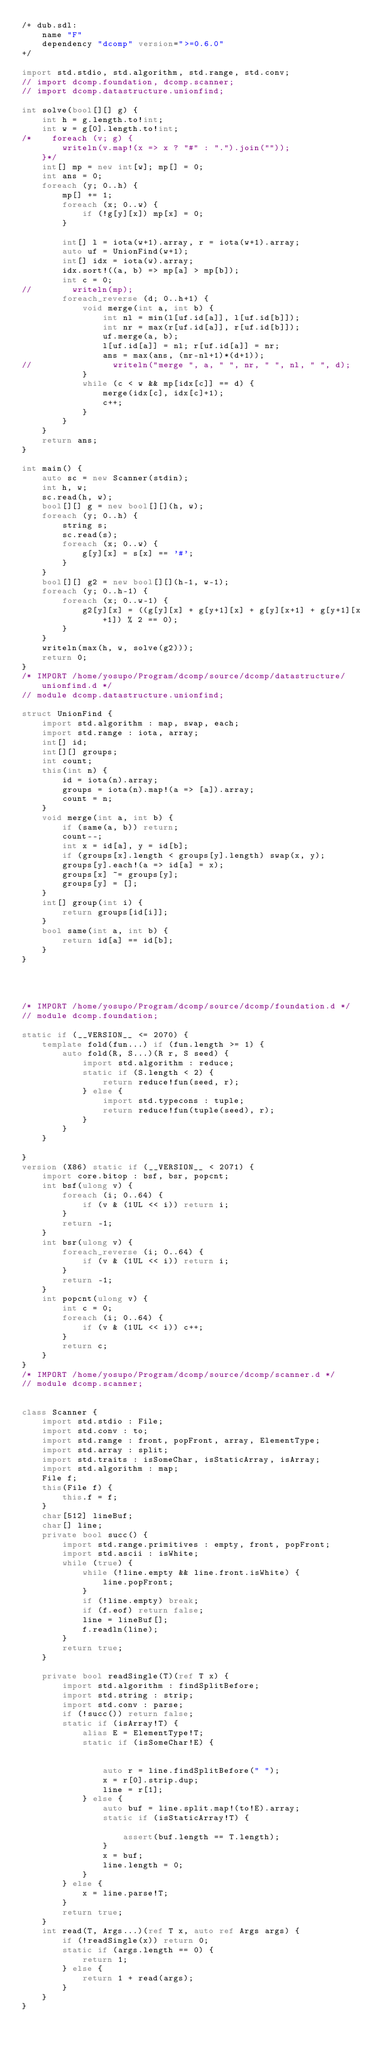Convert code to text. <code><loc_0><loc_0><loc_500><loc_500><_D_>/+ dub.sdl:
    name "F"
    dependency "dcomp" version=">=0.6.0"
+/

import std.stdio, std.algorithm, std.range, std.conv;
// import dcomp.foundation, dcomp.scanner;
// import dcomp.datastructure.unionfind;

int solve(bool[][] g) {
    int h = g.length.to!int;
    int w = g[0].length.to!int;
/*    foreach (v; g) {
        writeln(v.map!(x => x ? "#" : ".").join(""));
    }*/
    int[] mp = new int[w]; mp[] = 0;
    int ans = 0;
    foreach (y; 0..h) {
        mp[] += 1;
        foreach (x; 0..w) {
            if (!g[y][x]) mp[x] = 0;
        }

        int[] l = iota(w+1).array, r = iota(w+1).array;
        auto uf = UnionFind(w+1);
        int[] idx = iota(w).array;
        idx.sort!((a, b) => mp[a] > mp[b]);
        int c = 0;
//        writeln(mp);
        foreach_reverse (d; 0..h+1) {
            void merge(int a, int b) {
                int nl = min(l[uf.id[a]], l[uf.id[b]]);
                int nr = max(r[uf.id[a]], r[uf.id[b]]);
                uf.merge(a, b);
                l[uf.id[a]] = nl; r[uf.id[a]] = nr;
                ans = max(ans, (nr-nl+1)*(d+1));
//                writeln("merge ", a, " ", nr, " ", nl, " ", d);
            }
            while (c < w && mp[idx[c]] == d) {
                merge(idx[c], idx[c]+1);
                c++;
            }
        }
    }
    return ans;
}

int main() {
    auto sc = new Scanner(stdin);
    int h, w;
    sc.read(h, w);
    bool[][] g = new bool[][](h, w);
    foreach (y; 0..h) {
        string s;
        sc.read(s);
        foreach (x; 0..w) {
            g[y][x] = s[x] == '#';
        }
    }
    bool[][] g2 = new bool[][](h-1, w-1);
    foreach (y; 0..h-1) {
        foreach (x; 0..w-1) {
            g2[y][x] = ((g[y][x] + g[y+1][x] + g[y][x+1] + g[y+1][x+1]) % 2 == 0);
        }
    }
    writeln(max(h, w, solve(g2)));
    return 0;
}
/* IMPORT /home/yosupo/Program/dcomp/source/dcomp/datastructure/unionfind.d */
// module dcomp.datastructure.unionfind;

struct UnionFind {
    import std.algorithm : map, swap, each;
    import std.range : iota, array;
    int[] id;  
    int[][] groups;  
    int count;  
    this(int n) {
        id = iota(n).array;
        groups = iota(n).map!(a => [a]).array;
        count = n;
    }
    void merge(int a, int b) {
        if (same(a, b)) return;
        count--;
        int x = id[a], y = id[b];
        if (groups[x].length < groups[y].length) swap(x, y);
        groups[y].each!(a => id[a] = x);
        groups[x] ~= groups[y];
        groups[y] = [];
    }
    int[] group(int i) {
        return groups[id[i]];
    }
    bool same(int a, int b) {
        return id[a] == id[b];
    }
}

 

 
/* IMPORT /home/yosupo/Program/dcomp/source/dcomp/foundation.d */
// module dcomp.foundation;
 
static if (__VERSION__ <= 2070) {
    template fold(fun...) if (fun.length >= 1) {
        auto fold(R, S...)(R r, S seed) {
            import std.algorithm : reduce;
            static if (S.length < 2) {
                return reduce!fun(seed, r);
            } else {
                import std.typecons : tuple;
                return reduce!fun(tuple(seed), r);
            }
        }
    }
     
}
version (X86) static if (__VERSION__ < 2071) {
    import core.bitop : bsf, bsr, popcnt;
    int bsf(ulong v) {
        foreach (i; 0..64) {
            if (v & (1UL << i)) return i;
        }
        return -1;
    }
    int bsr(ulong v) {
        foreach_reverse (i; 0..64) {
            if (v & (1UL << i)) return i;
        }
        return -1;   
    }
    int popcnt(ulong v) {
        int c = 0;
        foreach (i; 0..64) {
            if (v & (1UL << i)) c++;
        }
        return c;
    }
}
/* IMPORT /home/yosupo/Program/dcomp/source/dcomp/scanner.d */
// module dcomp.scanner;

 
class Scanner {
    import std.stdio : File;
    import std.conv : to;
    import std.range : front, popFront, array, ElementType;
    import std.array : split;
    import std.traits : isSomeChar, isStaticArray, isArray; 
    import std.algorithm : map;
    File f;
    this(File f) {
        this.f = f;
    }
    char[512] lineBuf;
    char[] line;
    private bool succ() {
        import std.range.primitives : empty, front, popFront;
        import std.ascii : isWhite;
        while (true) {
            while (!line.empty && line.front.isWhite) {
                line.popFront;
            }
            if (!line.empty) break;
            if (f.eof) return false;
            line = lineBuf[];
            f.readln(line);
        }
        return true;
    }

    private bool readSingle(T)(ref T x) {
        import std.algorithm : findSplitBefore;
        import std.string : strip;
        import std.conv : parse;
        if (!succ()) return false;
        static if (isArray!T) {
            alias E = ElementType!T;
            static if (isSomeChar!E) {
                 
                 
                auto r = line.findSplitBefore(" ");
                x = r[0].strip.dup;
                line = r[1];
            } else {
                auto buf = line.split.map!(to!E).array;
                static if (isStaticArray!T) {
                     
                    assert(buf.length == T.length);
                }
                x = buf;
                line.length = 0;
            }
        } else {
            x = line.parse!T;
        }
        return true;
    }
    int read(T, Args...)(ref T x, auto ref Args args) {
        if (!readSingle(x)) return 0;
        static if (args.length == 0) {
            return 1;
        } else {
            return 1 + read(args);
        }
    }
}


 
 

 
</code> 